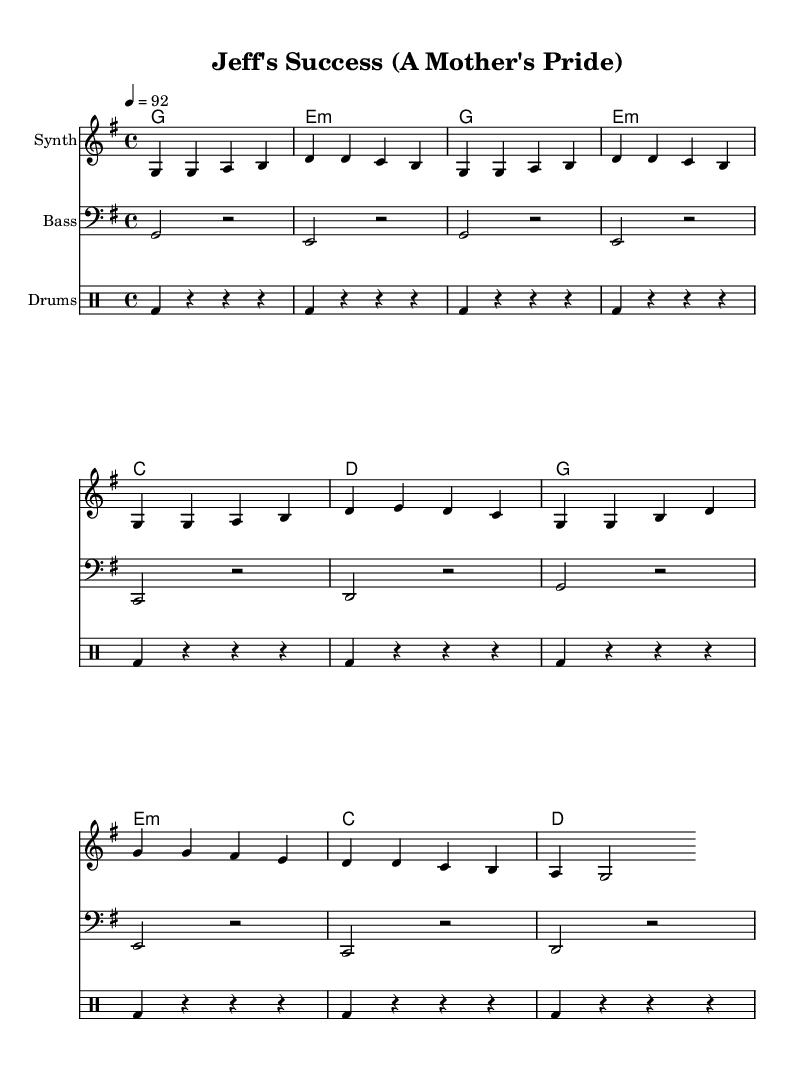What is the key signature of this music? The key signature is G major, which has one sharp (F#). This can be determined by looking at the first few measures where the key is indicated in the global settings.
Answer: G major What is the time signature of this music? The time signature is 4/4, as shown at the beginning of the piece in the global settings. This indicates that there are four beats per measure and a quarter note gets one beat.
Answer: 4/4 What is the tempo marking for this rap? The tempo marking indicates a tempo of 92 beats per minute, which is specified in the global settings. This tempo gives the rap a moderate pace suitable for expressive delivery.
Answer: 92 How many lines of lyrics are in the verse? The verse consists of four lines of lyrics, which can be counted from the lyric mode section provided. Each lyric line is separated by a space indicating a new line.
Answer: 4 During which section does the repetition of the phrase "Jeff Jefferys" occur? The phrase "Jeff Jefferys" is repeated in the verse, where it serves as a focal point for expressing parental pride. This can be identified by scanning through the lyric lines for the specific term.
Answer: Verse What type of rhyme scheme is used in the chorus? The rhyme scheme in the chorus utilizes an AABB pattern, where the first two lines rhyme with each other and the last two lines rhyme as well. This can be analyzed by examining the end words of each line in the chorus.
Answer: AABB Which instrument is responsible for the primary melody in this arrangement? The primary melody in this arrangement is played by the Synth, as indicated by the labeling of the staff. This information helps identify which instrument carries the main melodic line throughout the piece.
Answer: Synth 